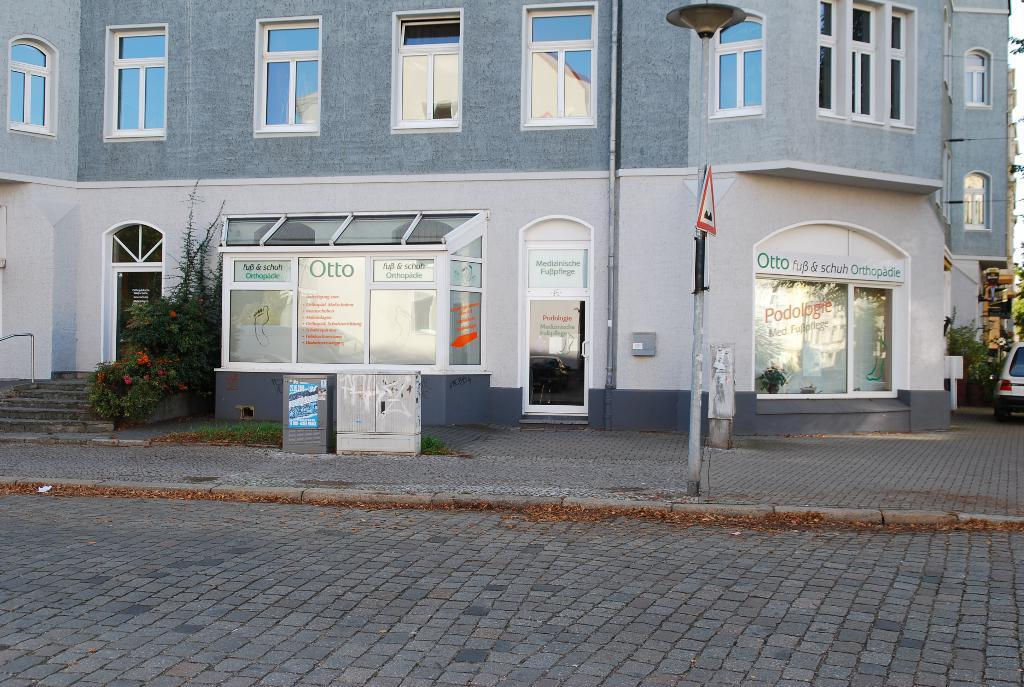What is the main subject of the image? There is a car in the image. What else can be seen in the image besides the car? There is a pole, plants, and a building in the background of the image. How many clams are attached to the car in the image? There are no clams present in the image; it features a car, a pole, plants, and a building in the background. 